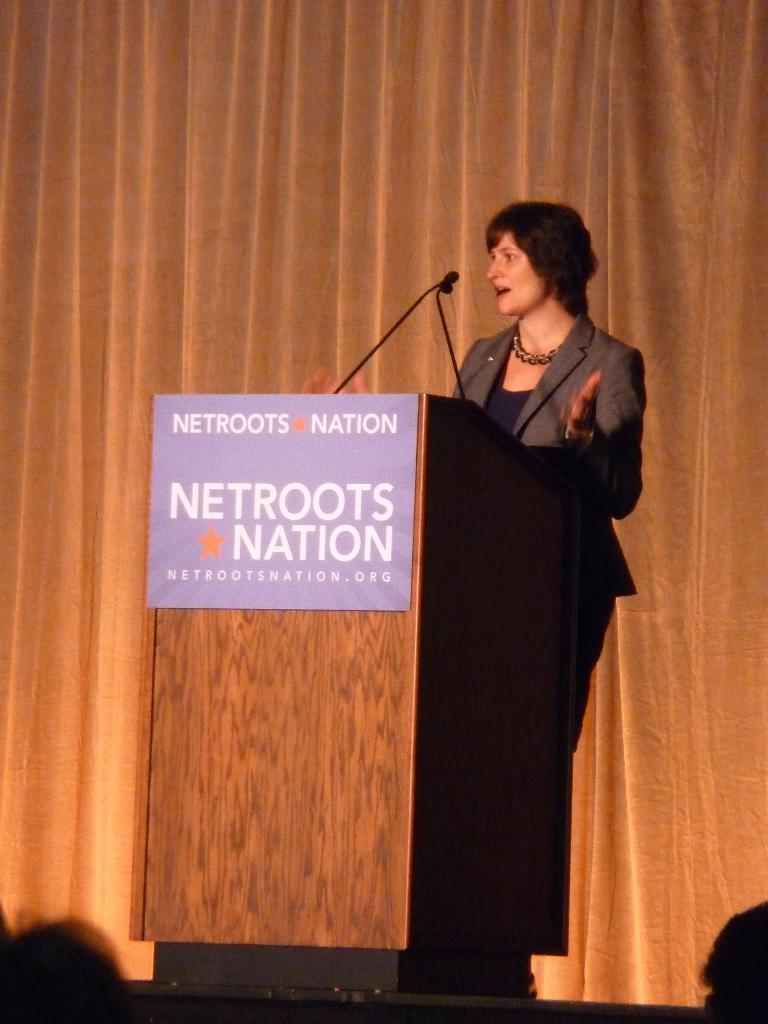<image>
Relay a brief, clear account of the picture shown. A podium at an event says Netroots Nation on it and has a red star. 